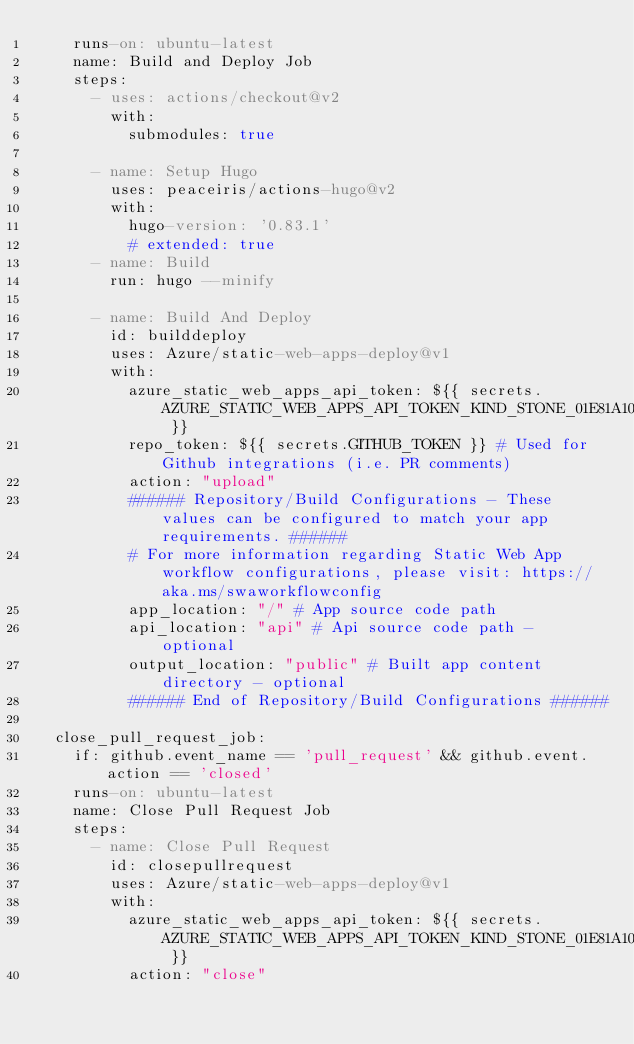Convert code to text. <code><loc_0><loc_0><loc_500><loc_500><_YAML_>    runs-on: ubuntu-latest
    name: Build and Deploy Job
    steps:
      - uses: actions/checkout@v2
        with:
          submodules: true

      - name: Setup Hugo
        uses: peaceiris/actions-hugo@v2
        with:
          hugo-version: '0.83.1'
          # extended: true
      - name: Build
        run: hugo --minify
        
      - name: Build And Deploy
        id: builddeploy
        uses: Azure/static-web-apps-deploy@v1
        with:
          azure_static_web_apps_api_token: ${{ secrets.AZURE_STATIC_WEB_APPS_API_TOKEN_KIND_STONE_01E81A103 }}
          repo_token: ${{ secrets.GITHUB_TOKEN }} # Used for Github integrations (i.e. PR comments)
          action: "upload"
          ###### Repository/Build Configurations - These values can be configured to match your app requirements. ######
          # For more information regarding Static Web App workflow configurations, please visit: https://aka.ms/swaworkflowconfig
          app_location: "/" # App source code path
          api_location: "api" # Api source code path - optional
          output_location: "public" # Built app content directory - optional
          ###### End of Repository/Build Configurations ######

  close_pull_request_job:
    if: github.event_name == 'pull_request' && github.event.action == 'closed'
    runs-on: ubuntu-latest
    name: Close Pull Request Job
    steps:
      - name: Close Pull Request
        id: closepullrequest
        uses: Azure/static-web-apps-deploy@v1
        with:
          azure_static_web_apps_api_token: ${{ secrets.AZURE_STATIC_WEB_APPS_API_TOKEN_KIND_STONE_01E81A103 }}
          action: "close"
</code> 